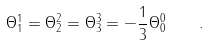<formula> <loc_0><loc_0><loc_500><loc_500>\Theta ^ { 1 } _ { 1 } = \Theta ^ { 2 } _ { 2 } = \Theta ^ { 3 } _ { 3 } = - \frac { 1 } { 3 } \Theta ^ { 0 } _ { 0 } \quad .</formula> 